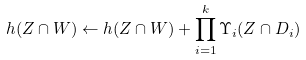<formula> <loc_0><loc_0><loc_500><loc_500>h ( Z \cap W ) \leftarrow h ( Z \cap W ) + \prod _ { i = 1 } ^ { k } \Upsilon _ { i } ( Z \cap D _ { i } )</formula> 